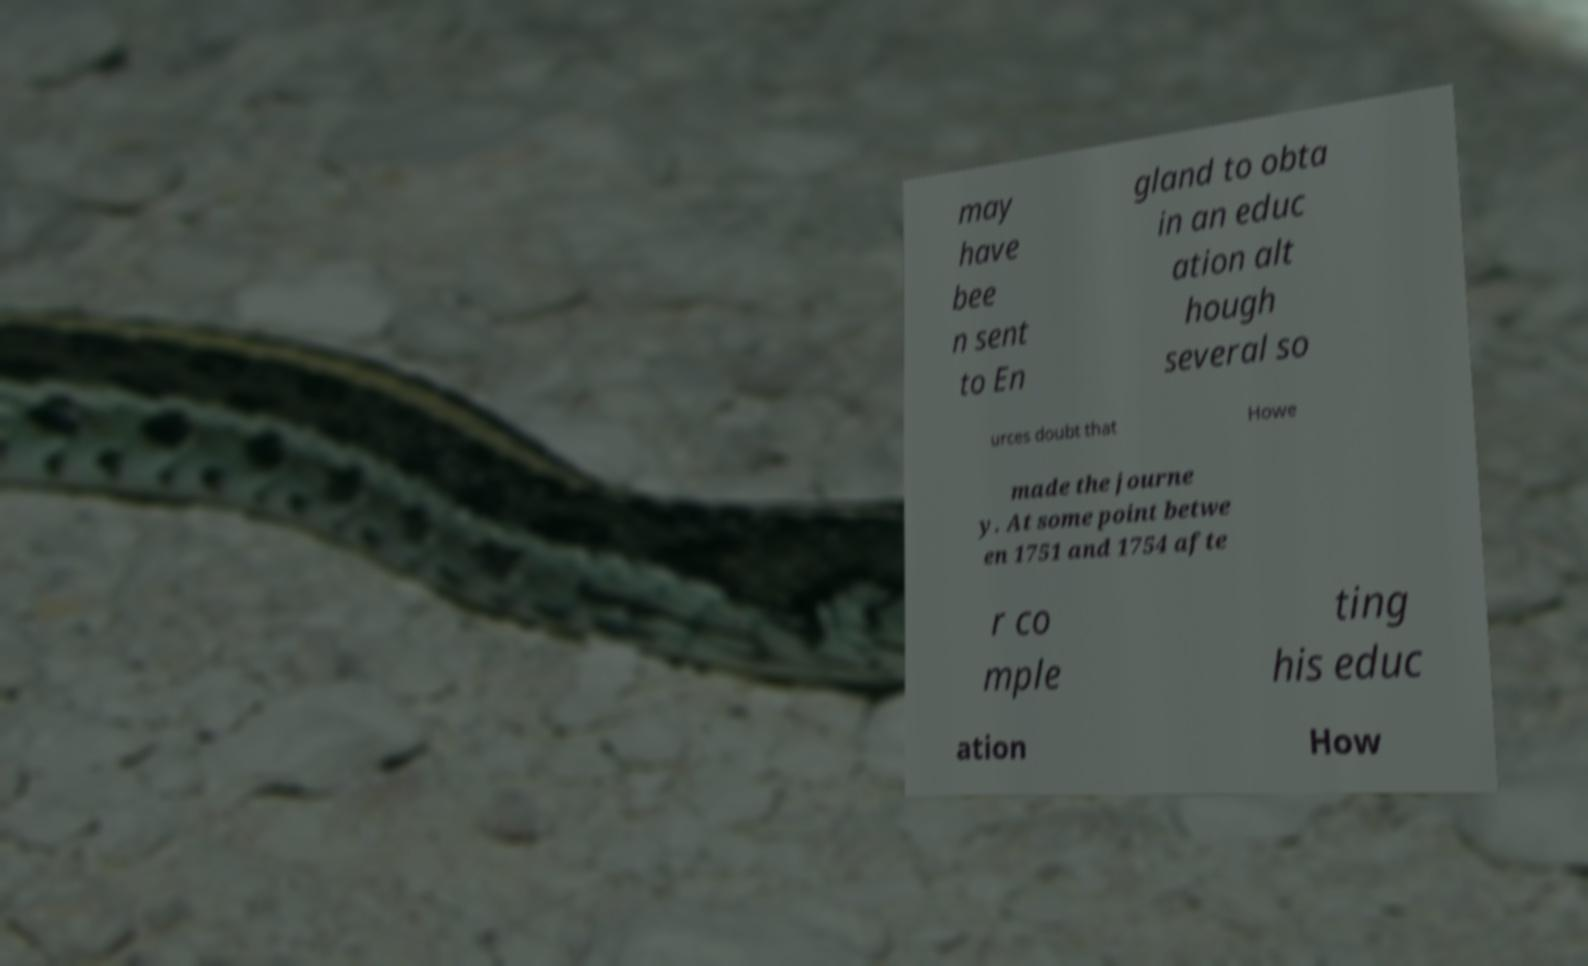Can you read and provide the text displayed in the image?This photo seems to have some interesting text. Can you extract and type it out for me? may have bee n sent to En gland to obta in an educ ation alt hough several so urces doubt that Howe made the journe y. At some point betwe en 1751 and 1754 afte r co mple ting his educ ation How 